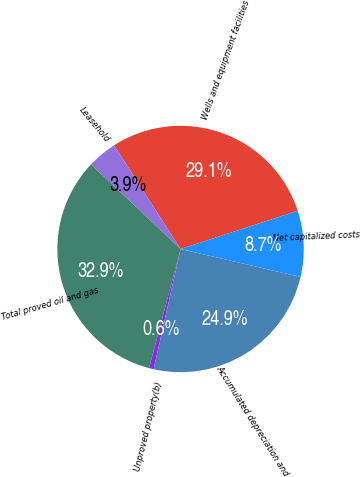Convert chart. <chart><loc_0><loc_0><loc_500><loc_500><pie_chart><fcel>Wells and equipment facilities<fcel>Leasehold<fcel>Total proved oil and gas<fcel>Unproved property(b)<fcel>Accumulated depreciation and<fcel>Net capitalized costs<nl><fcel>29.06%<fcel>3.87%<fcel>32.93%<fcel>0.61%<fcel>24.87%<fcel>8.66%<nl></chart> 